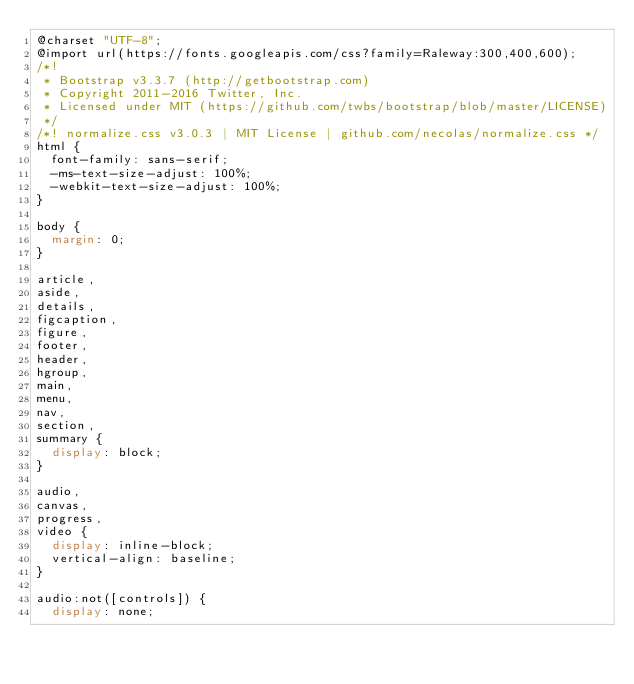<code> <loc_0><loc_0><loc_500><loc_500><_CSS_>@charset "UTF-8";
@import url(https://fonts.googleapis.com/css?family=Raleway:300,400,600);
/*!
 * Bootstrap v3.3.7 (http://getbootstrap.com)
 * Copyright 2011-2016 Twitter, Inc.
 * Licensed under MIT (https://github.com/twbs/bootstrap/blob/master/LICENSE)
 */
/*! normalize.css v3.0.3 | MIT License | github.com/necolas/normalize.css */
html {
  font-family: sans-serif;
  -ms-text-size-adjust: 100%;
  -webkit-text-size-adjust: 100%;
}

body {
  margin: 0;
}

article,
aside,
details,
figcaption,
figure,
footer,
header,
hgroup,
main,
menu,
nav,
section,
summary {
  display: block;
}

audio,
canvas,
progress,
video {
  display: inline-block;
  vertical-align: baseline;
}

audio:not([controls]) {
  display: none;</code> 